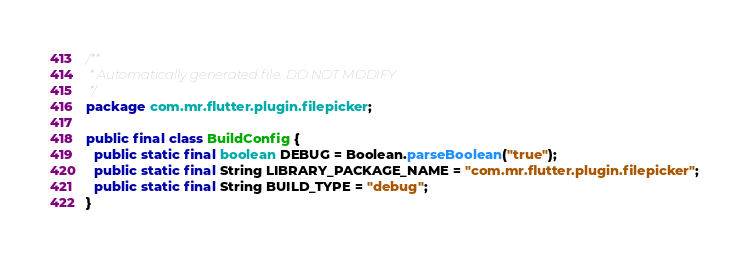Convert code to text. <code><loc_0><loc_0><loc_500><loc_500><_Java_>/**
 * Automatically generated file. DO NOT MODIFY
 */
package com.mr.flutter.plugin.filepicker;

public final class BuildConfig {
  public static final boolean DEBUG = Boolean.parseBoolean("true");
  public static final String LIBRARY_PACKAGE_NAME = "com.mr.flutter.plugin.filepicker";
  public static final String BUILD_TYPE = "debug";
}
</code> 